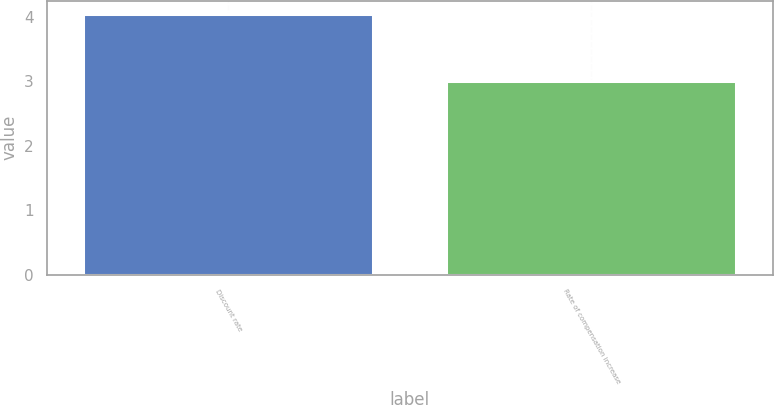<chart> <loc_0><loc_0><loc_500><loc_500><bar_chart><fcel>Discount rate<fcel>Rate of compensation increase<nl><fcel>4.05<fcel>3<nl></chart> 